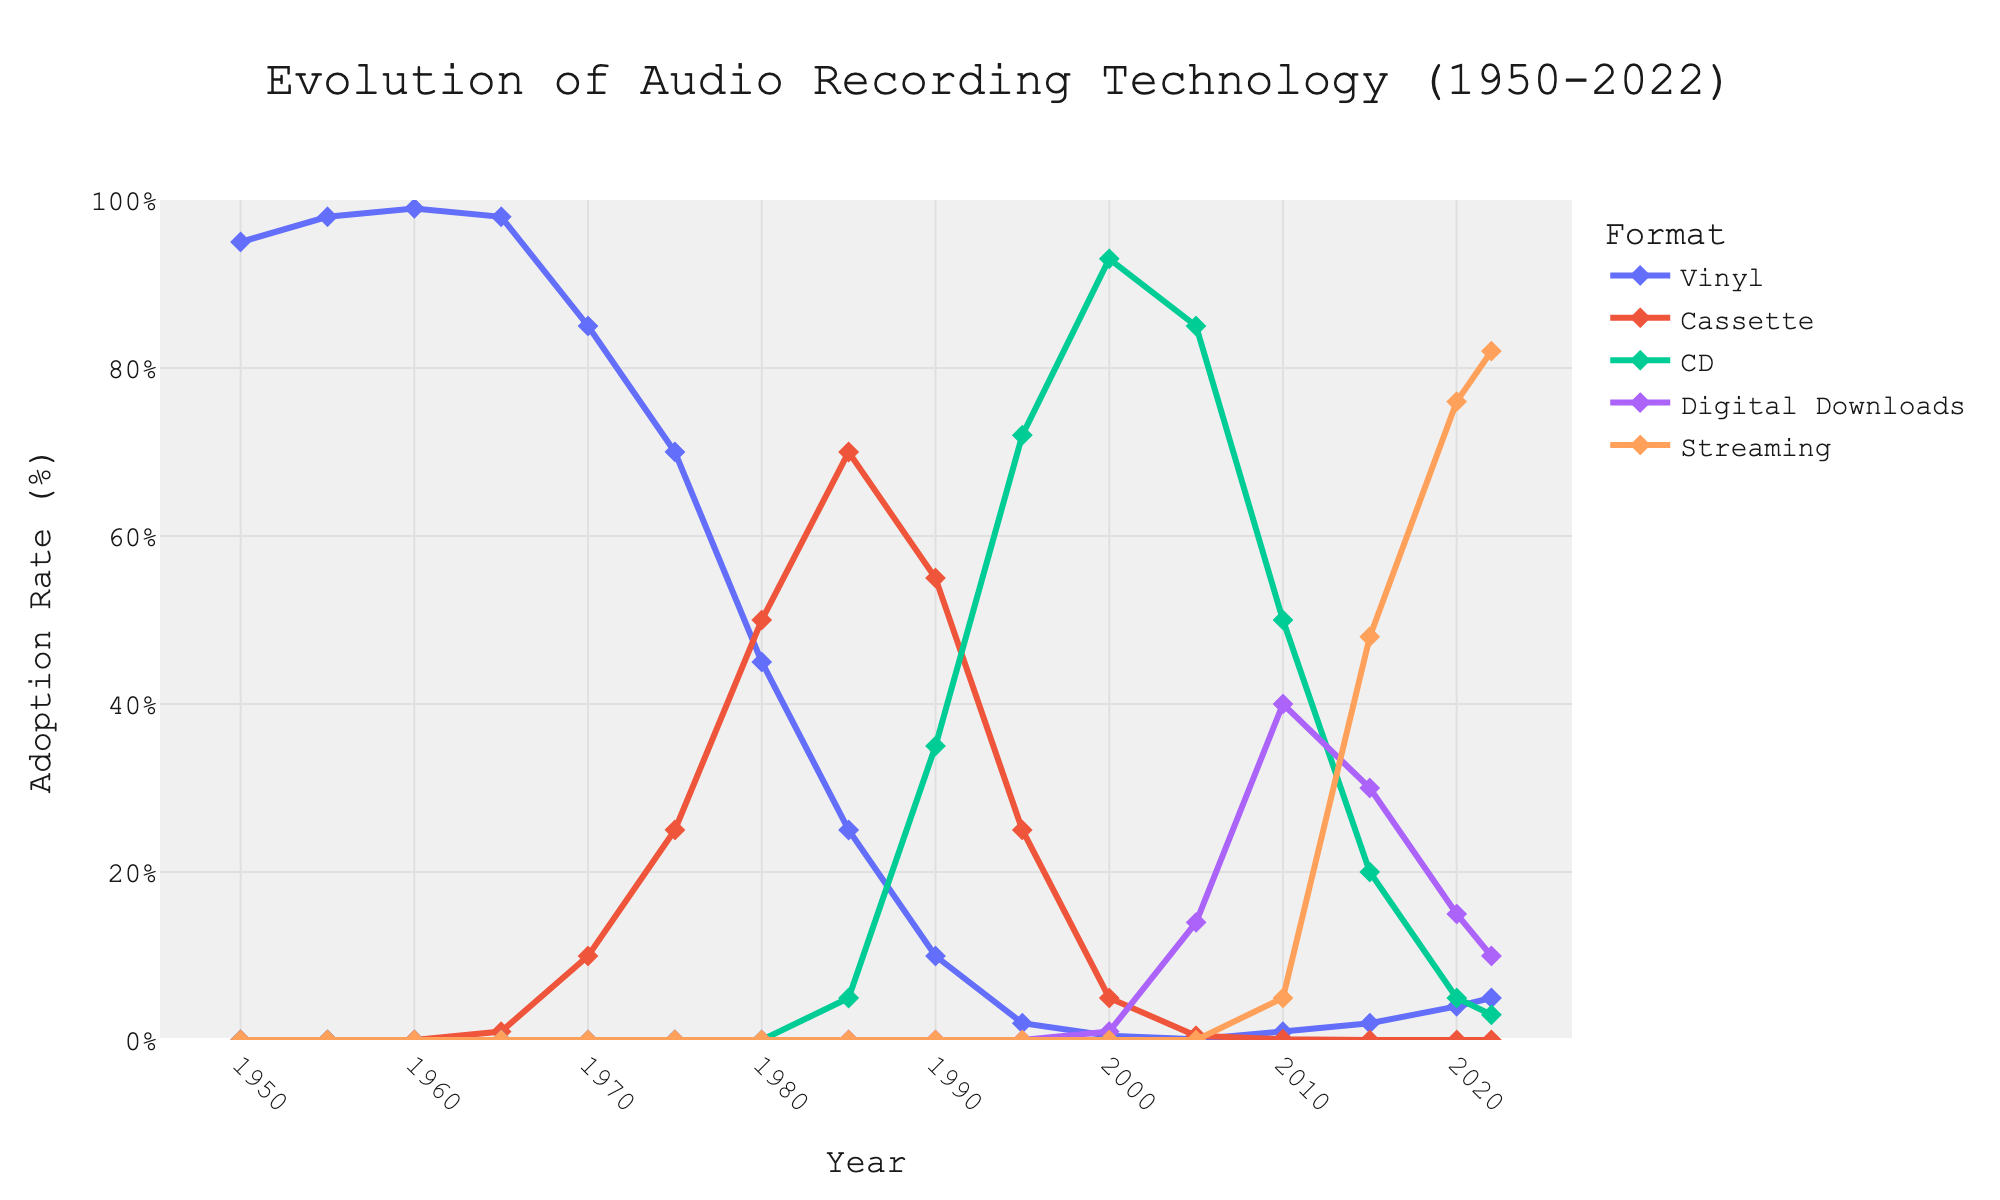What's the highest adoption rate for vinyl? Look at the vinyl line, its highest point is in 1960 at 99%.
Answer: 99% Which format has the highest adoption rate in 2022? Examine the adoption rates for each format in 2022. Streaming has the highest rate at 82%.
Answer: Streaming In what year did CDs surpass cassettes in adoption rate? Compare the lines for CD and cassette. In 1995, CD adoption rate (72%) surpassed cassette (25%).
Answer: 1995 How did the adoption rate for digital downloads change between 2010 and 2020? Look at the digital downloads line between 2010 and 2020. It started at 40% in 2010 and dropped to 15% in 2020.
Answer: Decreased What is the combined adoption rate of vinyl and cassettes in 1985? Sum the adoption rates of vinyl (25%) and cassettes (70%) in 1985.
Answer: 95% Which format experienced the most significant increase in adoption rate between 2000 and 2020? Examine the changes in adoption rate for each format from 2000 to 2020. Streaming increased from 0% to 76%.
Answer: Streaming At what year did streaming surpass other formats? Identify when streaming’s adoption rate exceeded other formats for the first time. In 2015, streaming’s adoption rate (48%) was higher than any other format.
Answer: 2015 What is the difference in adoption rates between CDs and digital downloads in 2005? Subtract the adoption rate of digital downloads (14%) from CDs (85%) in 2005.
Answer: 71% How did the adoption rates for CDs and digital downloads compare in 2010? Look at both CD and digital downloads lines in 2010. CDs had 50% and digital downloads 40%.
Answer: CDs higher What is the trend in vinyl adoption rate between 1950 and 2022? Observe the vinyl line from 1950 to 2022. It starts high, decreases sharply, and then slightly increases towards the end.
Answer: Decreasing overall 